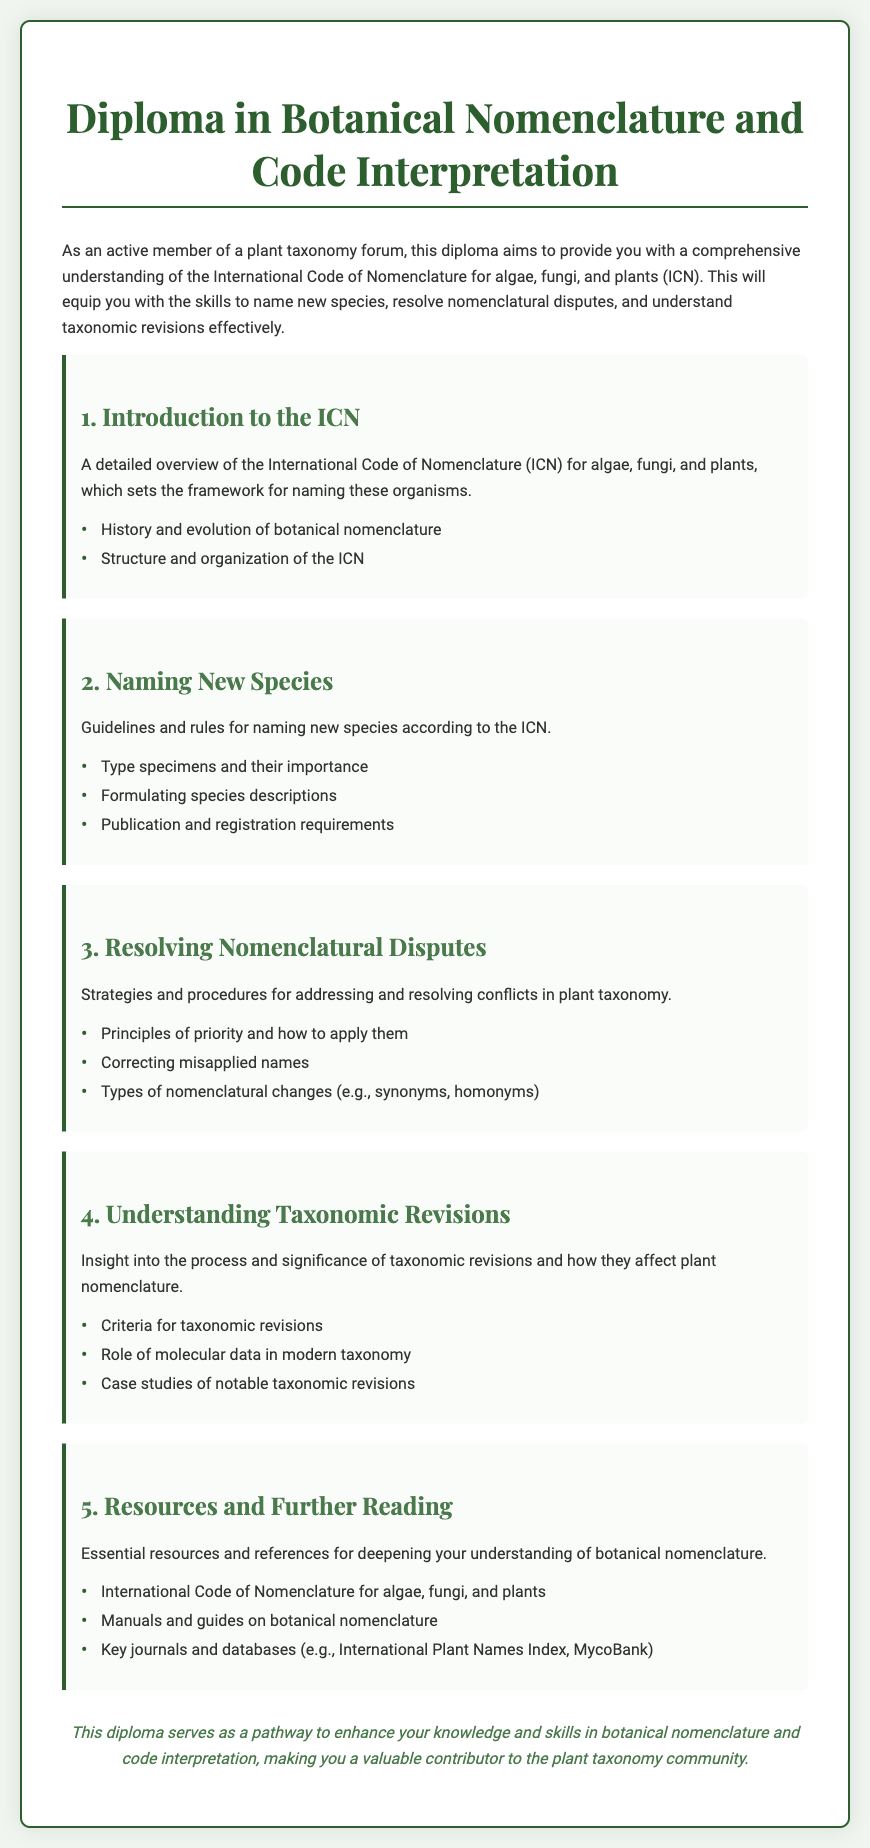What is the focus of the diploma? The diploma aims to provide a comprehensive understanding of the International Code of Nomenclature for algae, fungi, and plants (ICN).
Answer: comprehensive understanding of the International Code of Nomenclature for algae, fungi, and plants How many sections are in the diploma document? The document contains five main sections outlined in the diploma.
Answer: five What is the importance of type specimens? Type specimens are crucial for naming new species according to the ICN guidelines.
Answer: crucial for naming new species Which section discusses strategies for addressing nomenclatural conflicts? The section titled "Resolving Nomenclatural Disputes" covers strategies for addressing conflicts in taxonomy.
Answer: Resolving Nomenclatural Disputes What role does molecular data play in taxonomy? Molecular data plays a significant role in the understanding of taxonomic revisions mentioned in the diploma.
Answer: significant role in taxonomic revisions What does the conclusion of the diploma highlight? The conclusion emphasizes enhancing knowledge and skills in botanical nomenclature and code interpretation.
Answer: enhancing knowledge and skills What is the title of Section 5? The title of Section 5 is "Resources and Further Reading."
Answer: Resources and Further Reading What is a key journal mentioned in the resources section? The International Plant Names Index is listed as a key journal in the resources provided.
Answer: International Plant Names Index 